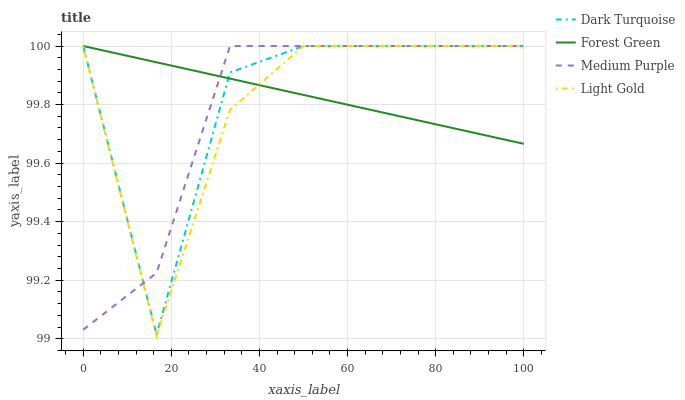Does Medium Purple have the minimum area under the curve?
Answer yes or no. Yes. Does Forest Green have the maximum area under the curve?
Answer yes or no. Yes. Does Dark Turquoise have the minimum area under the curve?
Answer yes or no. No. Does Dark Turquoise have the maximum area under the curve?
Answer yes or no. No. Is Forest Green the smoothest?
Answer yes or no. Yes. Is Dark Turquoise the roughest?
Answer yes or no. Yes. Is Dark Turquoise the smoothest?
Answer yes or no. No. Is Forest Green the roughest?
Answer yes or no. No. Does Dark Turquoise have the lowest value?
Answer yes or no. No. Does Light Gold have the highest value?
Answer yes or no. Yes. Does Dark Turquoise intersect Forest Green?
Answer yes or no. Yes. Is Dark Turquoise less than Forest Green?
Answer yes or no. No. Is Dark Turquoise greater than Forest Green?
Answer yes or no. No. 